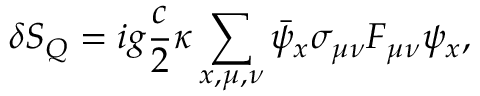<formula> <loc_0><loc_0><loc_500><loc_500>\delta S _ { Q } = i g \frac { c } { 2 } \kappa \sum _ { x , \mu , \nu } \bar { \psi } _ { x } \sigma _ { \mu \nu } F _ { \mu \nu } \psi _ { x } ,</formula> 